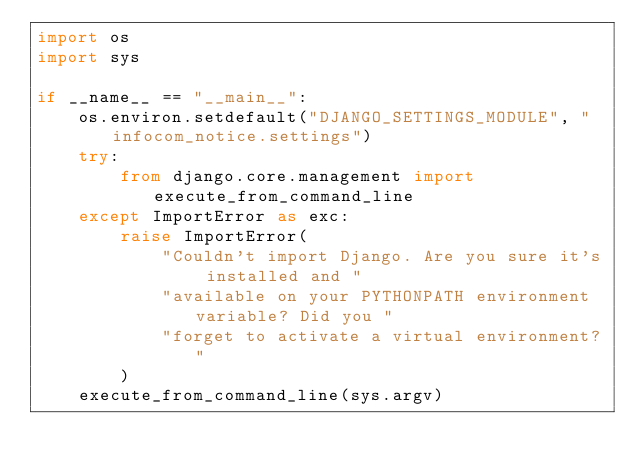Convert code to text. <code><loc_0><loc_0><loc_500><loc_500><_Python_>import os
import sys

if __name__ == "__main__":
    os.environ.setdefault("DJANGO_SETTINGS_MODULE", "infocom_notice.settings")
    try:
        from django.core.management import execute_from_command_line
    except ImportError as exc:
        raise ImportError(
            "Couldn't import Django. Are you sure it's installed and "
            "available on your PYTHONPATH environment variable? Did you "
            "forget to activate a virtual environment?"
        )
    execute_from_command_line(sys.argv)
</code> 